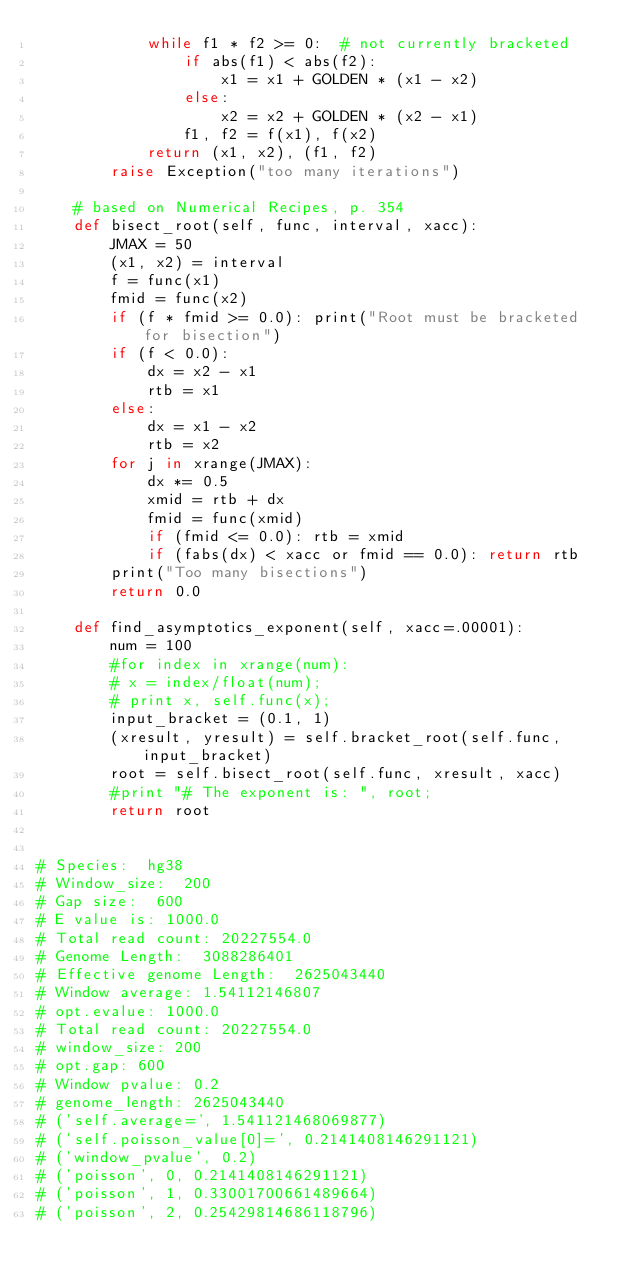<code> <loc_0><loc_0><loc_500><loc_500><_Cython_>            while f1 * f2 >= 0:  # not currently bracketed
                if abs(f1) < abs(f2):
                    x1 = x1 + GOLDEN * (x1 - x2)
                else:
                    x2 = x2 + GOLDEN * (x2 - x1)
                f1, f2 = f(x1), f(x2)
            return (x1, x2), (f1, f2)
        raise Exception("too many iterations")

    # based on Numerical Recipes, p. 354
    def bisect_root(self, func, interval, xacc):
        JMAX = 50
        (x1, x2) = interval
        f = func(x1)
        fmid = func(x2)
        if (f * fmid >= 0.0): print("Root must be bracketed for bisection")
        if (f < 0.0):
            dx = x2 - x1
            rtb = x1
        else:
            dx = x1 - x2
            rtb = x2
        for j in xrange(JMAX):
            dx *= 0.5
            xmid = rtb + dx
            fmid = func(xmid)
            if (fmid <= 0.0): rtb = xmid
            if (fabs(dx) < xacc or fmid == 0.0): return rtb
        print("Too many bisections")
        return 0.0

    def find_asymptotics_exponent(self, xacc=.00001):
        num = 100
        #for index in xrange(num):
        #	x = index/float(num);
        #	print x, self.func(x);
        input_bracket = (0.1, 1)
        (xresult, yresult) = self.bracket_root(self.func, input_bracket)
        root = self.bisect_root(self.func, xresult, xacc)
        #print "# The exponent is: ", root;
        return root


# Species:  hg38
# Window_size:  200
# Gap size:  600
# E value is: 1000.0
# Total read count: 20227554.0
# Genome Length:  3088286401
# Effective genome Length:  2625043440
# Window average: 1.54112146807
# opt.evalue: 1000.0
# Total read count: 20227554.0
# window_size: 200
# opt.gap: 600
# Window pvalue: 0.2
# genome_length: 2625043440
# ('self.average=', 1.541121468069877)
# ('self.poisson_value[0]=', 0.2141408146291121)
# ('window_pvalue', 0.2)
# ('poisson', 0, 0.2141408146291121)
# ('poisson', 1, 0.33001700661489664)
# ('poisson', 2, 0.25429814686118796)</code> 